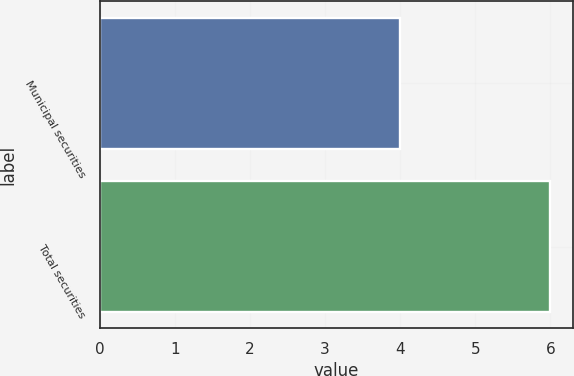Convert chart to OTSL. <chart><loc_0><loc_0><loc_500><loc_500><bar_chart><fcel>Municipal securities<fcel>Total securities<nl><fcel>4<fcel>6<nl></chart> 